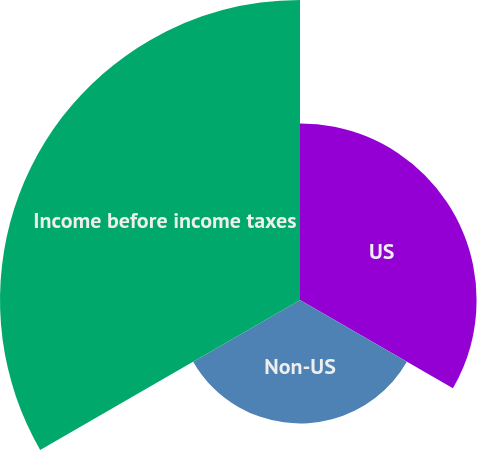Convert chart to OTSL. <chart><loc_0><loc_0><loc_500><loc_500><pie_chart><fcel>US<fcel>Non-US<fcel>Income before income taxes<nl><fcel>29.43%<fcel>20.57%<fcel>50.0%<nl></chart> 